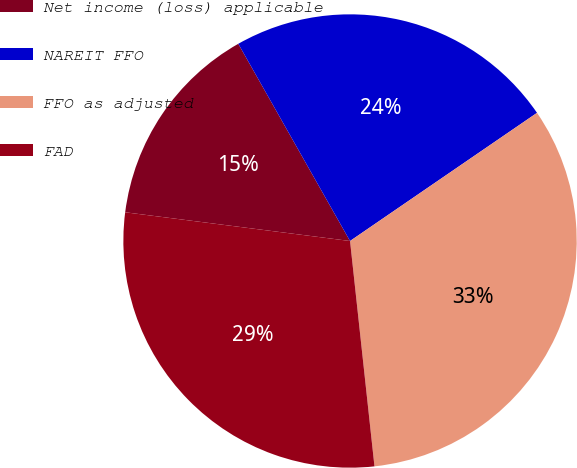Convert chart. <chart><loc_0><loc_0><loc_500><loc_500><pie_chart><fcel>Net income (loss) applicable<fcel>NAREIT FFO<fcel>FFO as adjusted<fcel>FAD<nl><fcel>14.77%<fcel>23.64%<fcel>32.84%<fcel>28.74%<nl></chart> 